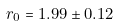Convert formula to latex. <formula><loc_0><loc_0><loc_500><loc_500>r _ { 0 } = 1 . 9 9 \pm 0 . 1 2</formula> 